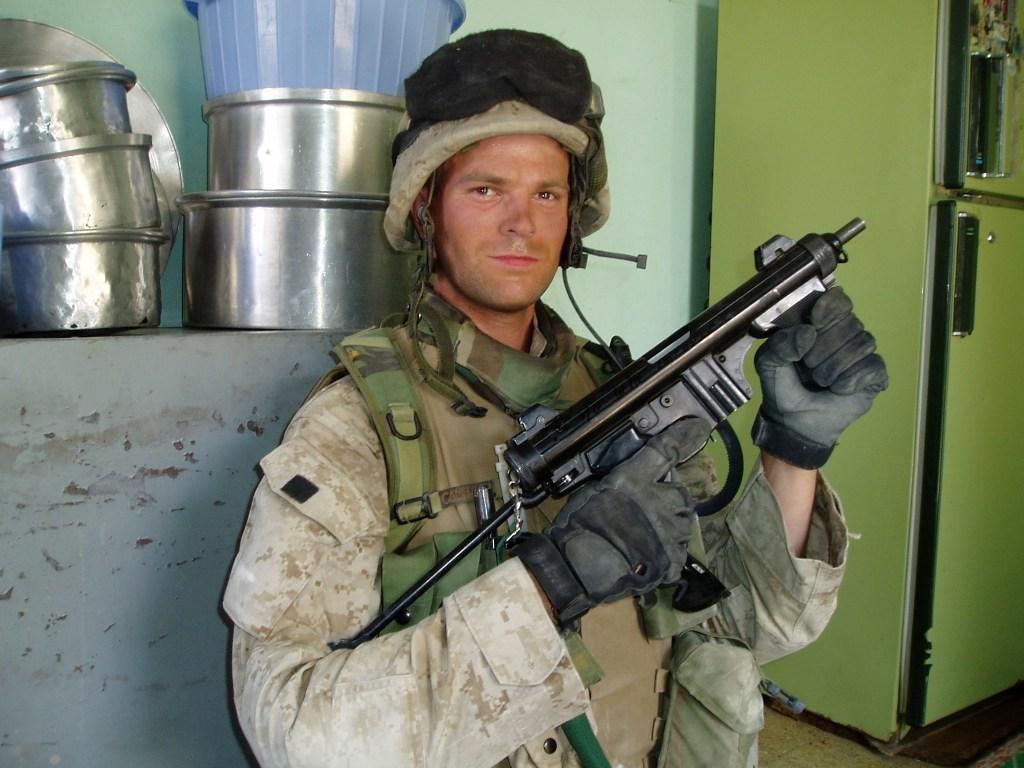In one or two sentences, can you explain what this image depicts? This image is taken indoors. In the background there is a wall. On the right side of the image there is a refrigerator. On the left side of the image there is a table and there are a few vessels on the table. There is a tab. In the middle of the image a man is standing and he is holding a gun in his hands. 